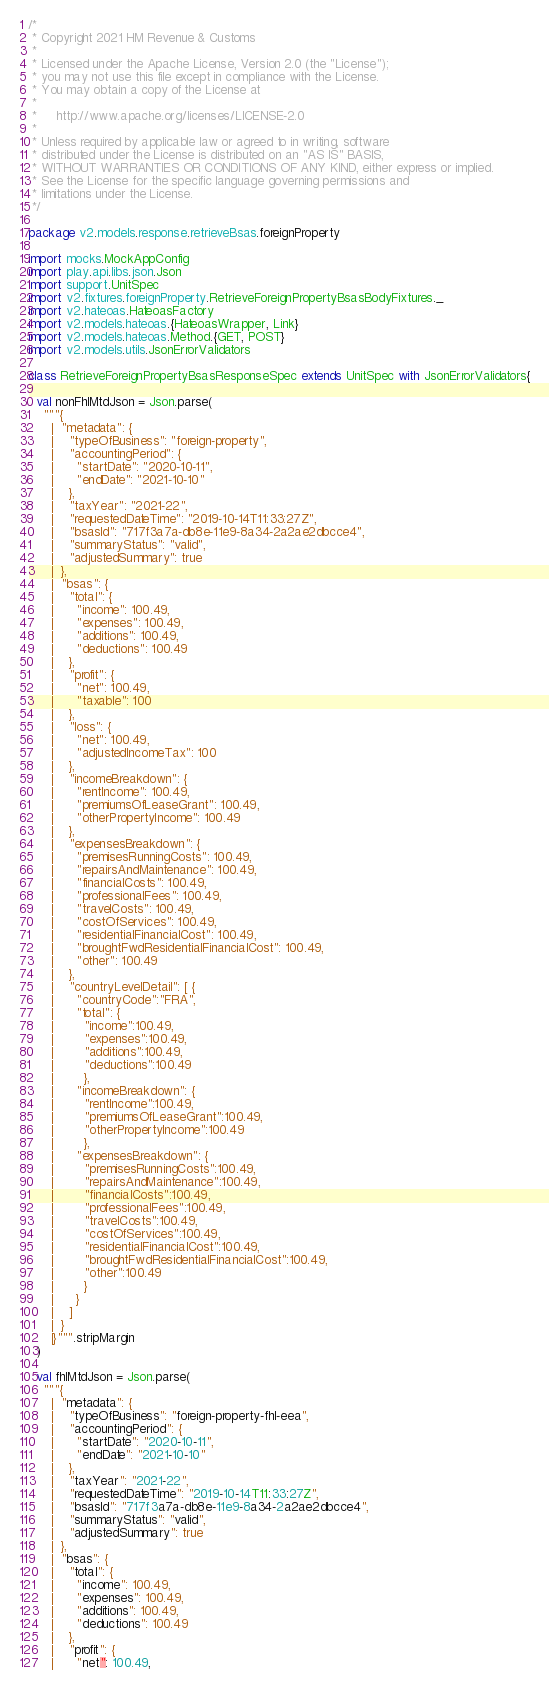Convert code to text. <code><loc_0><loc_0><loc_500><loc_500><_Scala_>/*
 * Copyright 2021 HM Revenue & Customs
 *
 * Licensed under the Apache License, Version 2.0 (the "License");
 * you may not use this file except in compliance with the License.
 * You may obtain a copy of the License at
 *
 *     http://www.apache.org/licenses/LICENSE-2.0
 *
 * Unless required by applicable law or agreed to in writing, software
 * distributed under the License is distributed on an "AS IS" BASIS,
 * WITHOUT WARRANTIES OR CONDITIONS OF ANY KIND, either express or implied.
 * See the License for the specific language governing permissions and
 * limitations under the License.
 */

package v2.models.response.retrieveBsas.foreignProperty

import mocks.MockAppConfig
import play.api.libs.json.Json
import support.UnitSpec
import v2.fixtures.foreignProperty.RetrieveForeignPropertyBsasBodyFixtures._
import v2.hateoas.HateoasFactory
import v2.models.hateoas.{HateoasWrapper, Link}
import v2.models.hateoas.Method.{GET, POST}
import v2.models.utils.JsonErrorValidators

class RetrieveForeignPropertyBsasResponseSpec extends UnitSpec with JsonErrorValidators{

  val nonFhlMtdJson = Json.parse(
    """{
      |  "metadata": {
      |    "typeOfBusiness": "foreign-property",
      |    "accountingPeriod": {
      |      "startDate": "2020-10-11",
      |      "endDate": "2021-10-10"
      |    },
      |    "taxYear": "2021-22",
      |    "requestedDateTime": "2019-10-14T11:33:27Z",
      |    "bsasId": "717f3a7a-db8e-11e9-8a34-2a2ae2dbcce4",
      |    "summaryStatus": "valid",
      |    "adjustedSummary": true
      |  },
      |  "bsas": {
      |    "total": {
      |      "income": 100.49,
      |      "expenses": 100.49,
      |      "additions": 100.49,
      |      "deductions": 100.49
      |    },
      |    "profit": {
      |      "net": 100.49,
      |      "taxable": 100
      |    },
      |    "loss": {
      |      "net": 100.49,
      |      "adjustedIncomeTax": 100
      |    },
      |    "incomeBreakdown": {
      |      "rentIncome": 100.49,
      |      "premiumsOfLeaseGrant": 100.49,
      |      "otherPropertyIncome": 100.49
      |    },
      |    "expensesBreakdown": {
      |      "premisesRunningCosts": 100.49,
      |      "repairsAndMaintenance": 100.49,
      |      "financialCosts": 100.49,
      |      "professionalFees": 100.49,
      |      "travelCosts": 100.49,
      |      "costOfServices": 100.49,
      |      "residentialFinancialCost": 100.49,
      |      "broughtFwdResidentialFinancialCost": 100.49,
      |      "other": 100.49
      |    },
      |    "countryLevelDetail": [ {
      |      "countryCode":"FRA",
      |      "total": {
      |        "income":100.49,
      |        "expenses":100.49,
      |        "additions":100.49,
      |        "deductions":100.49
      |        },
      |      "incomeBreakdown": {
      |        "rentIncome":100.49,
      |        "premiumsOfLeaseGrant":100.49,
      |        "otherPropertyIncome":100.49
      |        },
      |      "expensesBreakdown": {
      |        "premisesRunningCosts":100.49,
      |        "repairsAndMaintenance":100.49,
      |        "financialCosts":100.49,
      |        "professionalFees":100.49,
      |        "travelCosts":100.49,
      |        "costOfServices":100.49,
      |        "residentialFinancialCost":100.49,
      |        "broughtFwdResidentialFinancialCost":100.49,
      |        "other":100.49
      |        }
      |      }
      |    ]
      |  }
      |}""".stripMargin
  )

  val fhlMtdJson = Json.parse(
    """{
      |  "metadata": {
      |    "typeOfBusiness": "foreign-property-fhl-eea",
      |    "accountingPeriod": {
      |      "startDate": "2020-10-11",
      |      "endDate": "2021-10-10"
      |    },
      |    "taxYear": "2021-22",
      |    "requestedDateTime": "2019-10-14T11:33:27Z",
      |    "bsasId": "717f3a7a-db8e-11e9-8a34-2a2ae2dbcce4",
      |    "summaryStatus": "valid",
      |    "adjustedSummary": true
      |  },
      |  "bsas": {
      |    "total": {
      |      "income": 100.49,
      |      "expenses": 100.49,
      |      "additions": 100.49,
      |      "deductions": 100.49
      |    },
      |    "profit": {
      |      "net": 100.49,</code> 